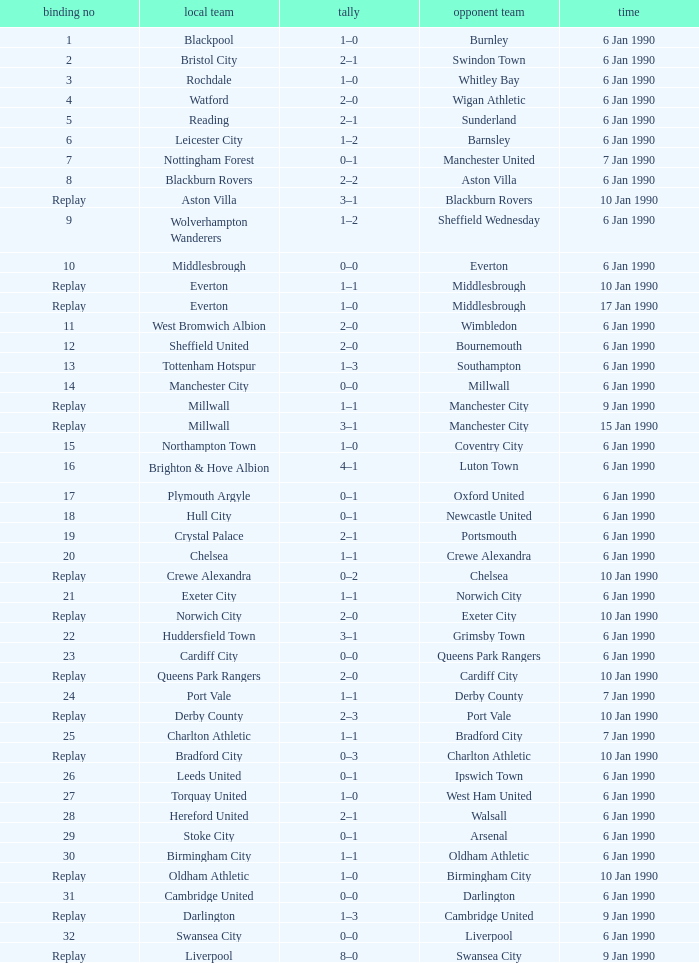What was the score of the game against away team crewe alexandra? 1–1. 